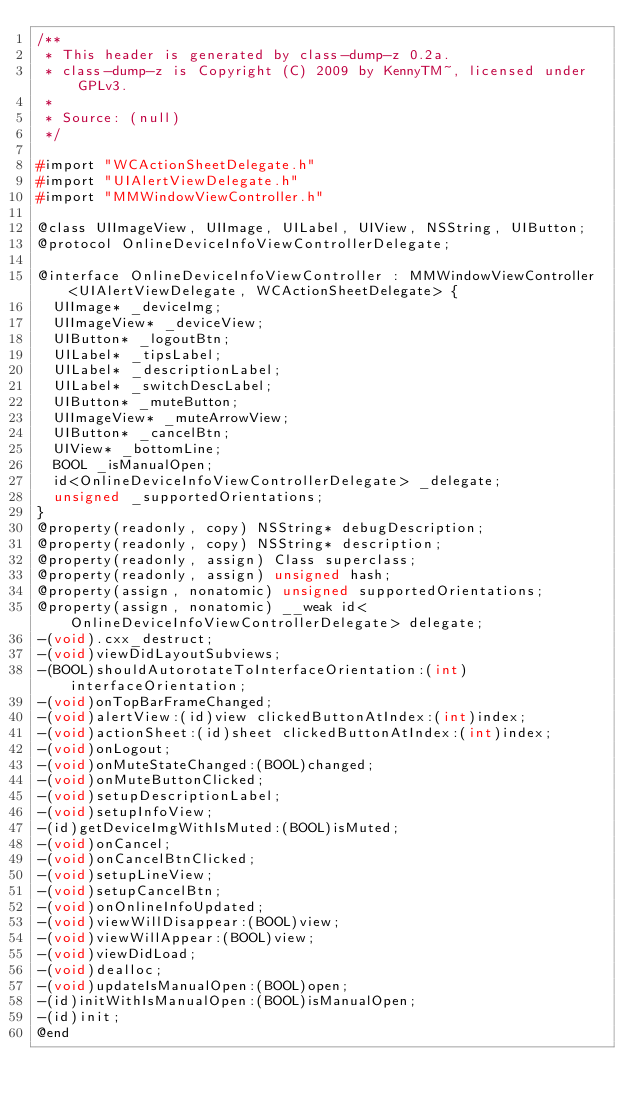Convert code to text. <code><loc_0><loc_0><loc_500><loc_500><_C_>/**
 * This header is generated by class-dump-z 0.2a.
 * class-dump-z is Copyright (C) 2009 by KennyTM~, licensed under GPLv3.
 *
 * Source: (null)
 */

#import "WCActionSheetDelegate.h"
#import "UIAlertViewDelegate.h"
#import "MMWindowViewController.h"

@class UIImageView, UIImage, UILabel, UIView, NSString, UIButton;
@protocol OnlineDeviceInfoViewControllerDelegate;

@interface OnlineDeviceInfoViewController : MMWindowViewController <UIAlertViewDelegate, WCActionSheetDelegate> {
	UIImage* _deviceImg;
	UIImageView* _deviceView;
	UIButton* _logoutBtn;
	UILabel* _tipsLabel;
	UILabel* _descriptionLabel;
	UILabel* _switchDescLabel;
	UIButton* _muteButton;
	UIImageView* _muteArrowView;
	UIButton* _cancelBtn;
	UIView* _bottomLine;
	BOOL _isManualOpen;
	id<OnlineDeviceInfoViewControllerDelegate> _delegate;
	unsigned _supportedOrientations;
}
@property(readonly, copy) NSString* debugDescription;
@property(readonly, copy) NSString* description;
@property(readonly, assign) Class superclass;
@property(readonly, assign) unsigned hash;
@property(assign, nonatomic) unsigned supportedOrientations;
@property(assign, nonatomic) __weak id<OnlineDeviceInfoViewControllerDelegate> delegate;
-(void).cxx_destruct;
-(void)viewDidLayoutSubviews;
-(BOOL)shouldAutorotateToInterfaceOrientation:(int)interfaceOrientation;
-(void)onTopBarFrameChanged;
-(void)alertView:(id)view clickedButtonAtIndex:(int)index;
-(void)actionSheet:(id)sheet clickedButtonAtIndex:(int)index;
-(void)onLogout;
-(void)onMuteStateChanged:(BOOL)changed;
-(void)onMuteButtonClicked;
-(void)setupDescriptionLabel;
-(void)setupInfoView;
-(id)getDeviceImgWithIsMuted:(BOOL)isMuted;
-(void)onCancel;
-(void)onCancelBtnClicked;
-(void)setupLineView;
-(void)setupCancelBtn;
-(void)onOnlineInfoUpdated;
-(void)viewWillDisappear:(BOOL)view;
-(void)viewWillAppear:(BOOL)view;
-(void)viewDidLoad;
-(void)dealloc;
-(void)updateIsManualOpen:(BOOL)open;
-(id)initWithIsManualOpen:(BOOL)isManualOpen;
-(id)init;
@end

</code> 